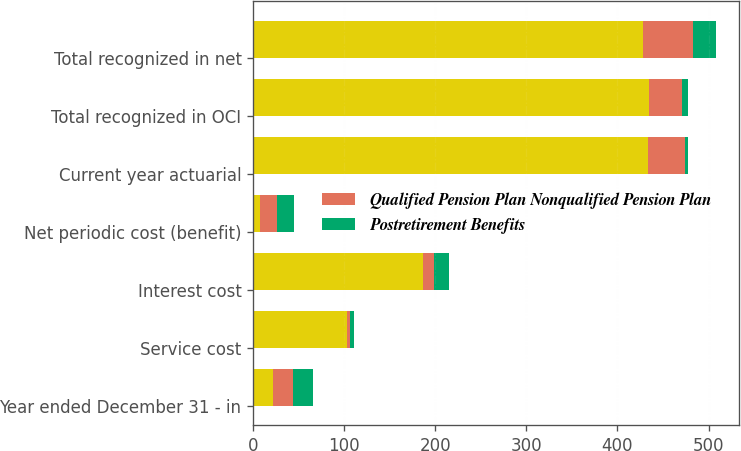<chart> <loc_0><loc_0><loc_500><loc_500><stacked_bar_chart><ecel><fcel>Year ended December 31 - in<fcel>Service cost<fcel>Interest cost<fcel>Net periodic cost (benefit)<fcel>Current year actuarial<fcel>Total recognized in OCI<fcel>Total recognized in net<nl><fcel>nan<fcel>22<fcel>103<fcel>187<fcel>7<fcel>434<fcel>435<fcel>428<nl><fcel>Qualified Pension Plan Nonqualified Pension Plan<fcel>22<fcel>3<fcel>12<fcel>19<fcel>40<fcel>36<fcel>55<nl><fcel>Postretirement Benefits<fcel>22<fcel>5<fcel>16<fcel>19<fcel>4<fcel>6<fcel>25<nl></chart> 